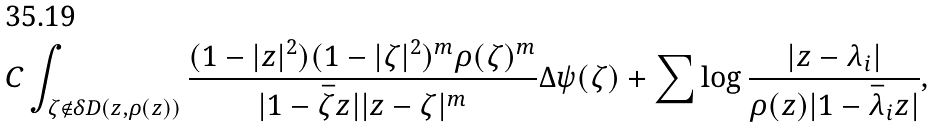<formula> <loc_0><loc_0><loc_500><loc_500>C \int _ { \zeta \notin \delta D ( z , \rho ( z ) ) } \frac { ( 1 - | z | ^ { 2 } ) ( 1 - | \zeta | ^ { 2 } ) ^ { m } \rho ( \zeta ) ^ { m } } { | 1 - \bar { \zeta } z | | z - \zeta | ^ { m } } \Delta \psi ( \zeta ) + \sum \log \frac { | z - \lambda _ { i } | } { \rho ( z ) | 1 - \bar { \lambda } _ { i } z | } ,</formula> 